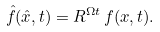Convert formula to latex. <formula><loc_0><loc_0><loc_500><loc_500>\hat { f } ( \hat { x } , t ) = R ^ { \Omega t } \, f ( x , t ) .</formula> 